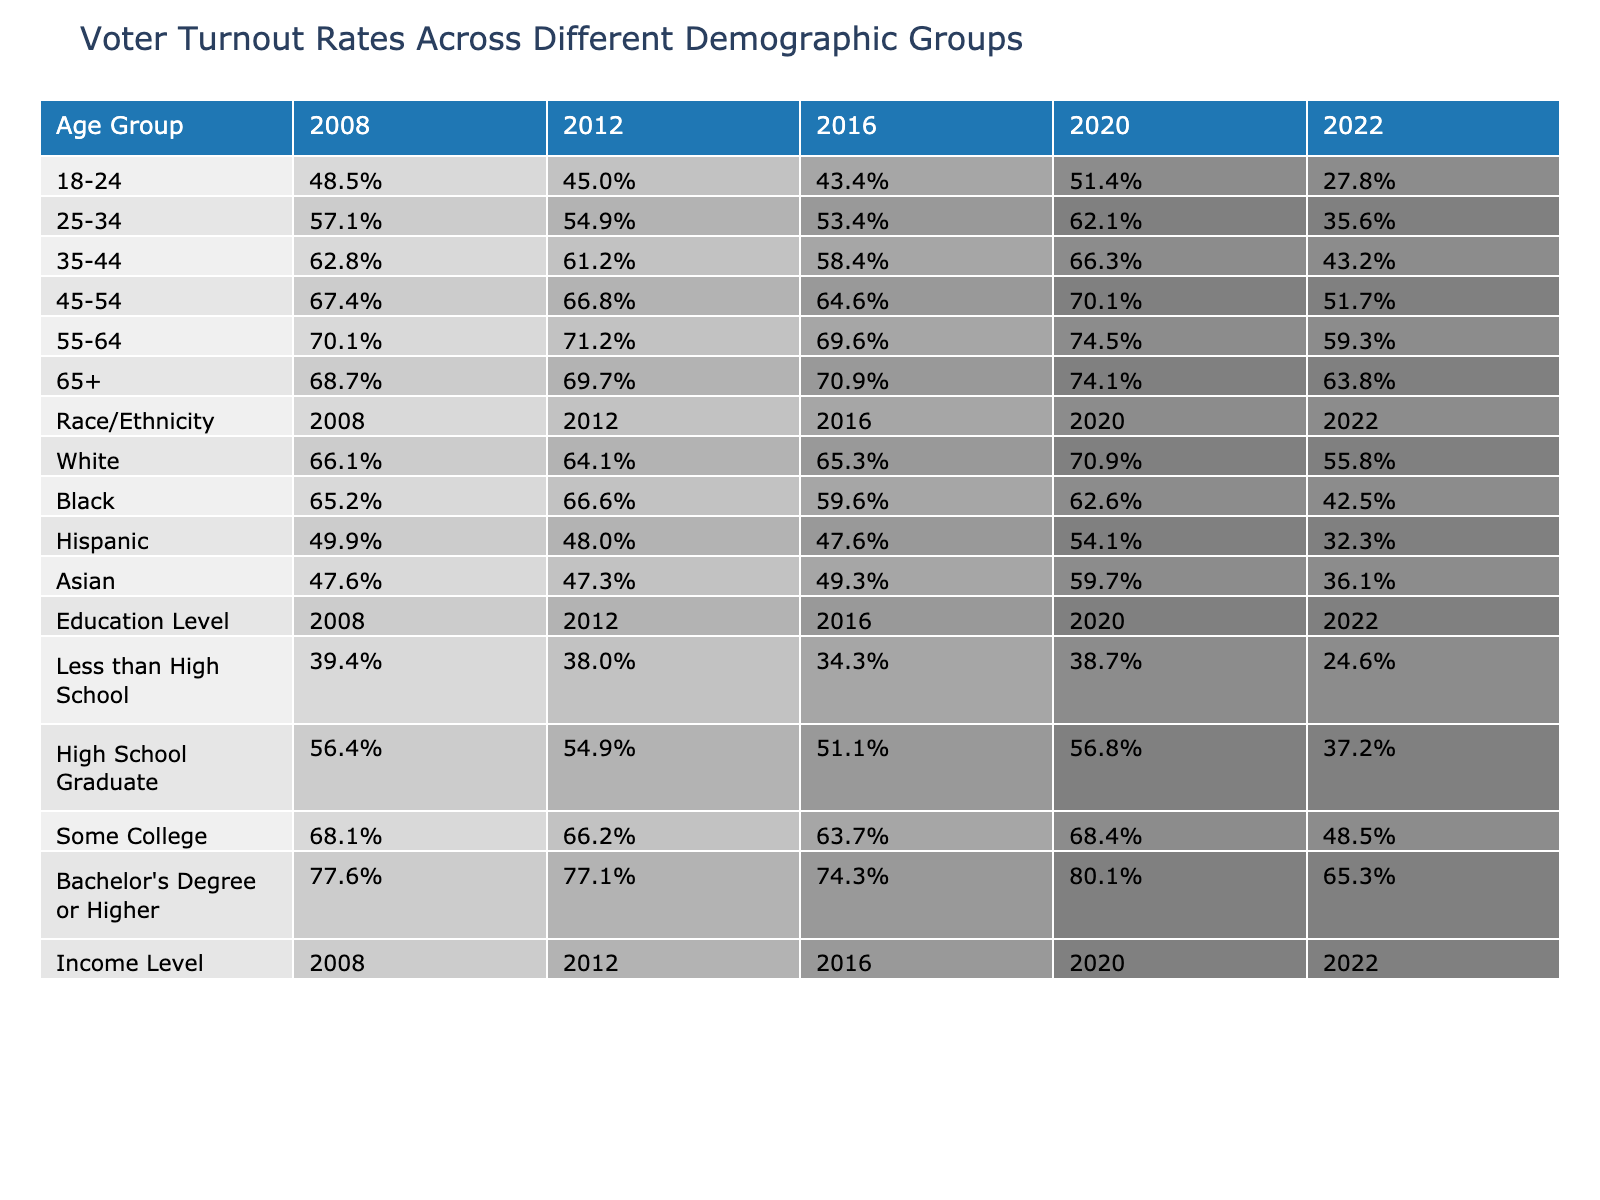What was the voter turnout rate for the 18-24 age group in the 2020 election? The table shows a voter turnout rate of 51.4% for the 18-24 age group in the 2020 election.
Answer: 51.4% Which age group had the highest voter turnout rate in 2022? From the data, the 55-64 age group had the highest turnout rate of 59.3% in 2022.
Answer: 55-64 What is the average voter turnout for the Black demographic across all five elections? The turnout rates for Black voters over the five elections are 65.2%, 66.6%, 59.6%, 62.6%, and 42.5%. Summing these values gives 296.5%, and dividing by 5 gives an average of 59.3%.
Answer: 59.3% Did the voter turnout rate for Hispanic voters increase in the 2020 election compared to the 2016 election? The turnout for Hispanic voters in 2016 was 47.6% and in 2020 it was 54.1%. Since 54.1% is greater than 47.6%, the turnout did increase.
Answer: Yes What was the difference in voter turnout for the 25-34 age group between 2008 and 2022? The turnout for 25-34 age group in 2008 was 57.1%, and in 2022 it was 35.6%. The difference is 57.1% - 35.6% = 21.5%.
Answer: 21.5% Which demographic group had a voter turnout below 40% in any election year? The data shows that in 2022, the voter turnout rate for the Less than High School demographic dropped to 24.6%, which is below 40%.
Answer: Yes What was the trend in voter turnout for those with a Bachelor's degree or higher from 2008 to 2022? The turnout for those with a Bachelor's degree or higher was 77.6% in 2008, decreased slightly to 77.1% in 2012, further dropped to 74.3% in 2016, then increased to 80.1% in 2020, and ended at 65.3% in 2022. The overall trend shows the turnout fluctuated without a consistent increase or decrease.
Answer: Fluctuating How much lower was the voter turnout for the 18-24 age group in 2022 compared to 2008? The voter turnout in 2008 for the 18-24 age group was 48.5%, and in 2022 it was 27.8%. The difference is 48.5% - 27.8% = 20.7%.
Answer: 20.7% In which election year did the White demographic experience the largest decrease in voter turnout compared to the previous election? Comparing the turnout rates for the White demographic, it decreased from 66.1% in 2008 to 64.1% in 2012 (a decrease of 2.0%), but the largest decrease occurred from 2020 (70.9%) to 2022 (55.8%), which is a decrease of 15.1%.
Answer: 2022 Is there a consistent increase in voter turnout across all age groups from 2008 to 2020? Examining each age group's turnout, there was growth from 2008 to 2020 for all age groups, with each showing higher rates in 2020 than in 2008, indicating a consistent increase.
Answer: Yes 